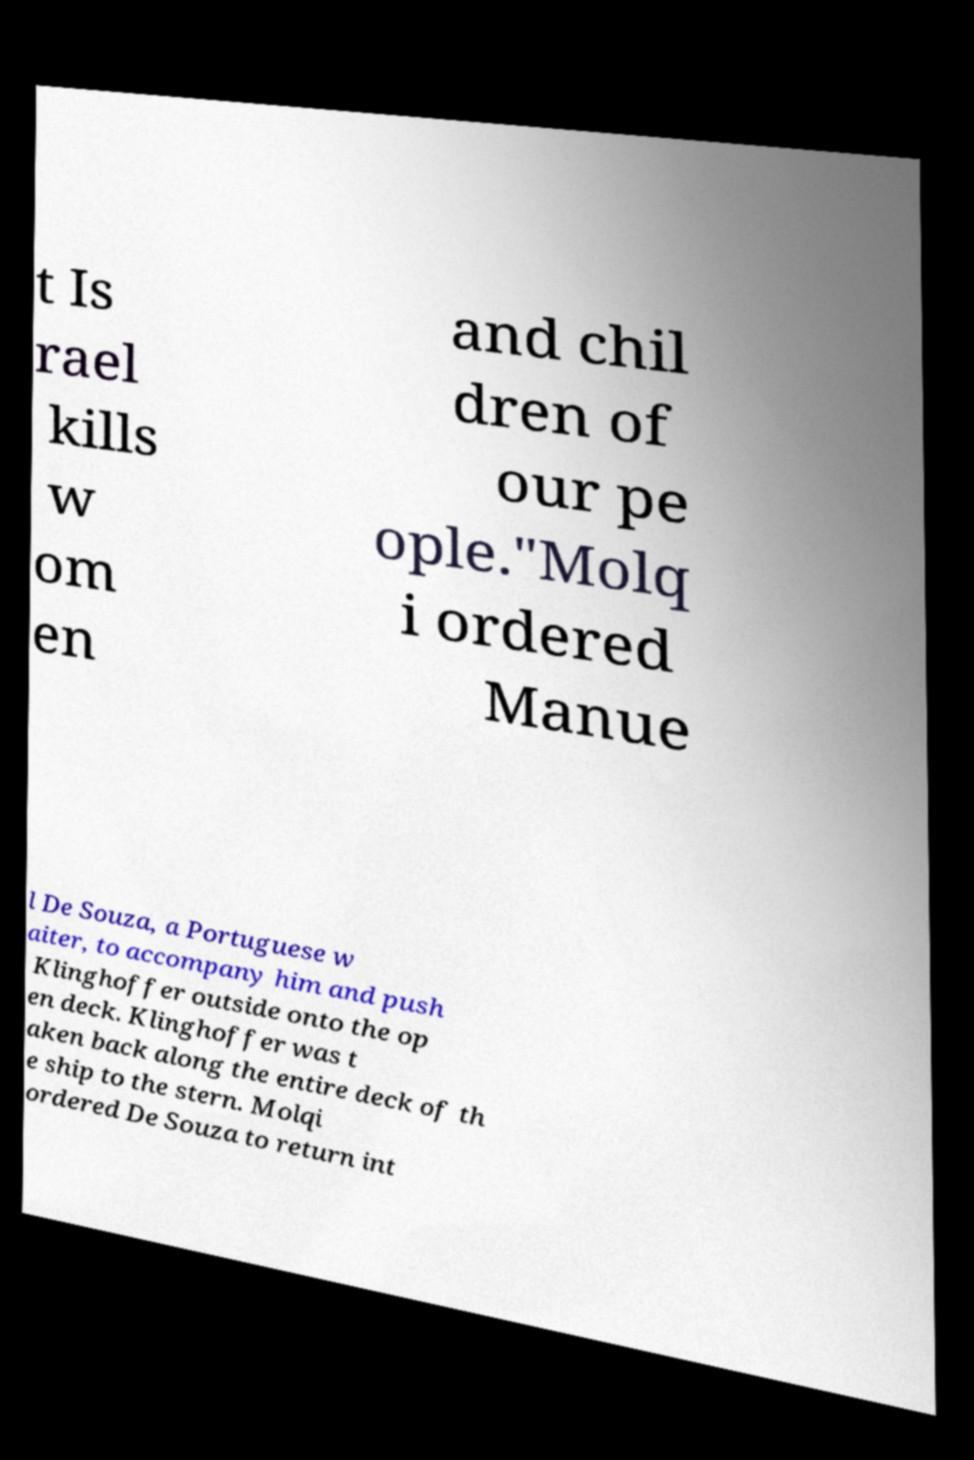Could you extract and type out the text from this image? t Is rael kills w om en and chil dren of our pe ople."Molq i ordered Manue l De Souza, a Portuguese w aiter, to accompany him and push Klinghoffer outside onto the op en deck. Klinghoffer was t aken back along the entire deck of th e ship to the stern. Molqi ordered De Souza to return int 